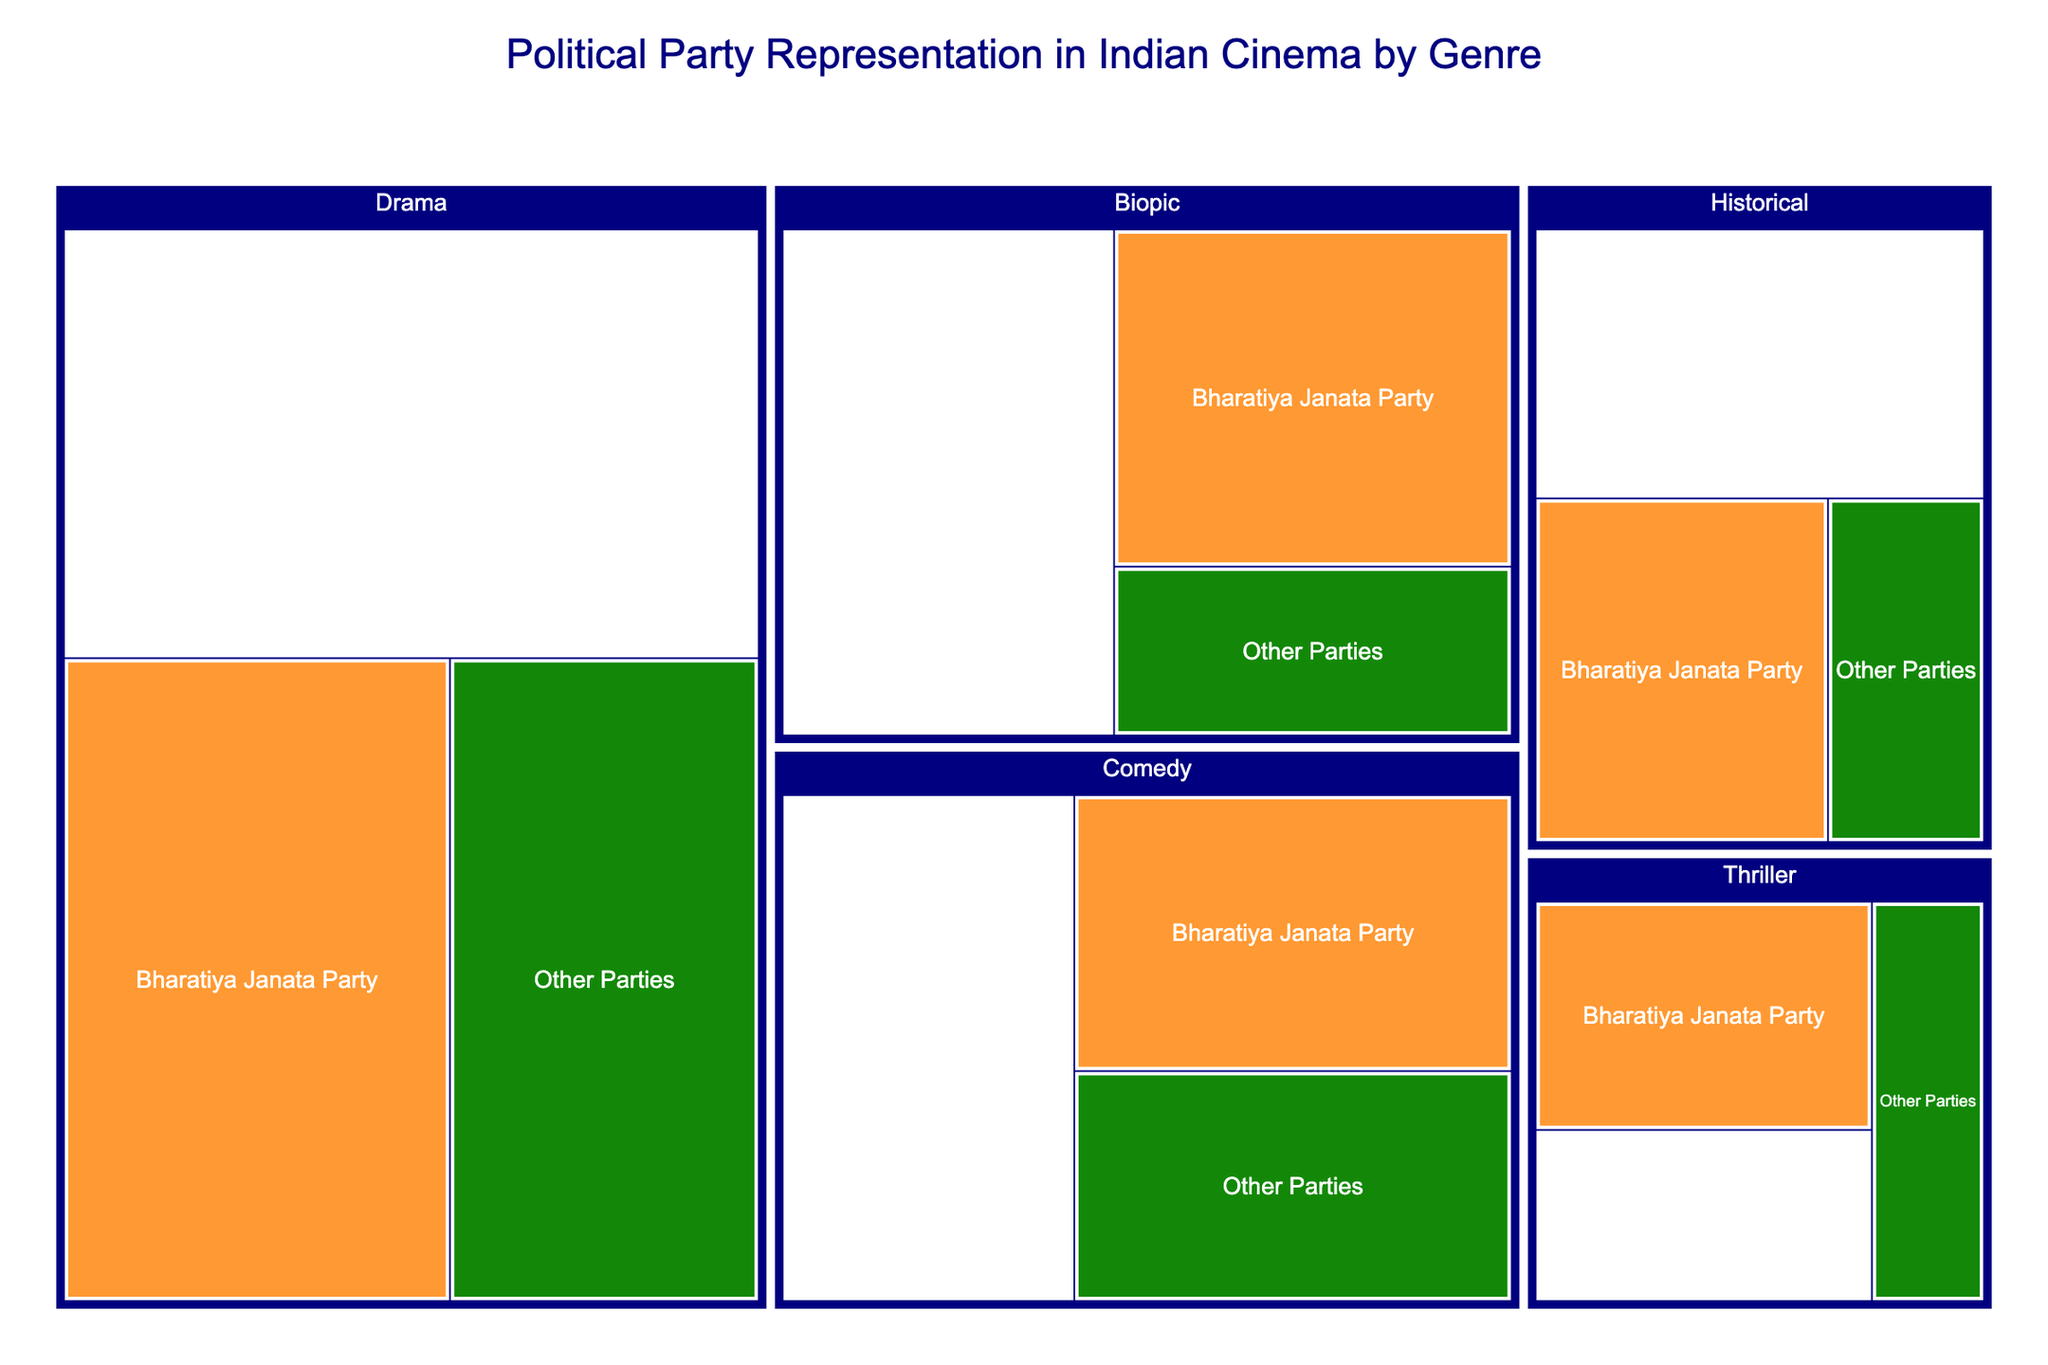Which genre has the highest number of films representing the Indian National Congress? From the treemap, locate the Indian National Congress section and within it find the genre with the largest Film Count.
Answer: Drama Which political party has the least representation in Thriller films? From the Thriller section, compare the Film Count for each party, and identify the one with the smallest count.
Answer: Other Parties What is the total number of films representing the Bharatiya Janata Party across all genres? Sum the Film Counts for the Bharatiya Janata Party across Drama, Comedy, Thriller, Biopic, and Historical genres: 35 + 18 + 12 + 20 + 15 = 100
Answer: 100 Which genre has the most balanced representation among the three parties? Identify the genre where the differences in Film Count between parties are the smallest. Compare the counts across genres such as Drama, Comedy, Thriller, Biopic, and Historical.
Answer: Historical How does the number of Comedy films representing the Indian National Congress compare to those representing Other Parties? From the Comedy section, compare the Film Count for Indian National Congress (22) to Other Parties (15).
Answer: Indian National Congress has more Comedy films In which genre does the Bharatiya Janata Party have the highest representation? From the treemap, compare the Bharatiya Janata Party's Film Counts across all genres and identify the highest.
Answer: Drama Are there more Thriller or Biopic films representing Other Parties? Compare the Film Count for Other Parties in the Thriller (7) and Biopic (10) sections.
Answer: Biopic What is the overall representation difference between Bharatiya Janata Party and Indian National Congress in Drama? Subtract the Film Count for Bharatiya Janata Party in Drama (35) from the Film Count for Indian National Congress in Drama (42): 42 - 35 = 7
Answer: 7 How many more films represent the Bharatiya Janata Party than Other Parties in the Biopic genre? Subtract the Film Count for Other Parties in Biopic (10) from the Film Count for Bharatiya Janata Party in Biopic (20): 20 - 10 = 10
Answer: 10 